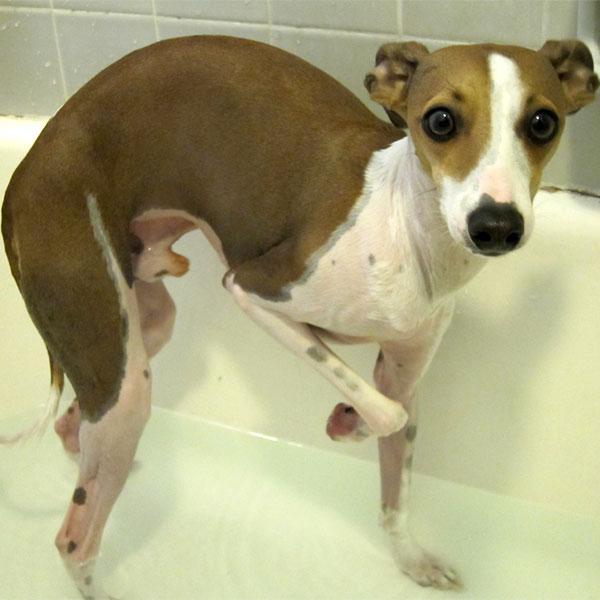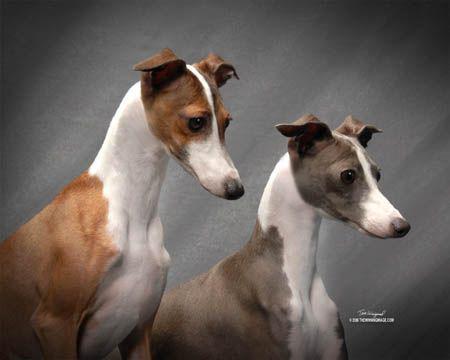The first image is the image on the left, the second image is the image on the right. Given the left and right images, does the statement "The dog in one of the images is holding one paw up." hold true? Answer yes or no. Yes. The first image is the image on the left, the second image is the image on the right. Examine the images to the left and right. Is the description "At least one image in the pair contains a dog standing up with all four legs on the ground." accurate? Answer yes or no. No. 